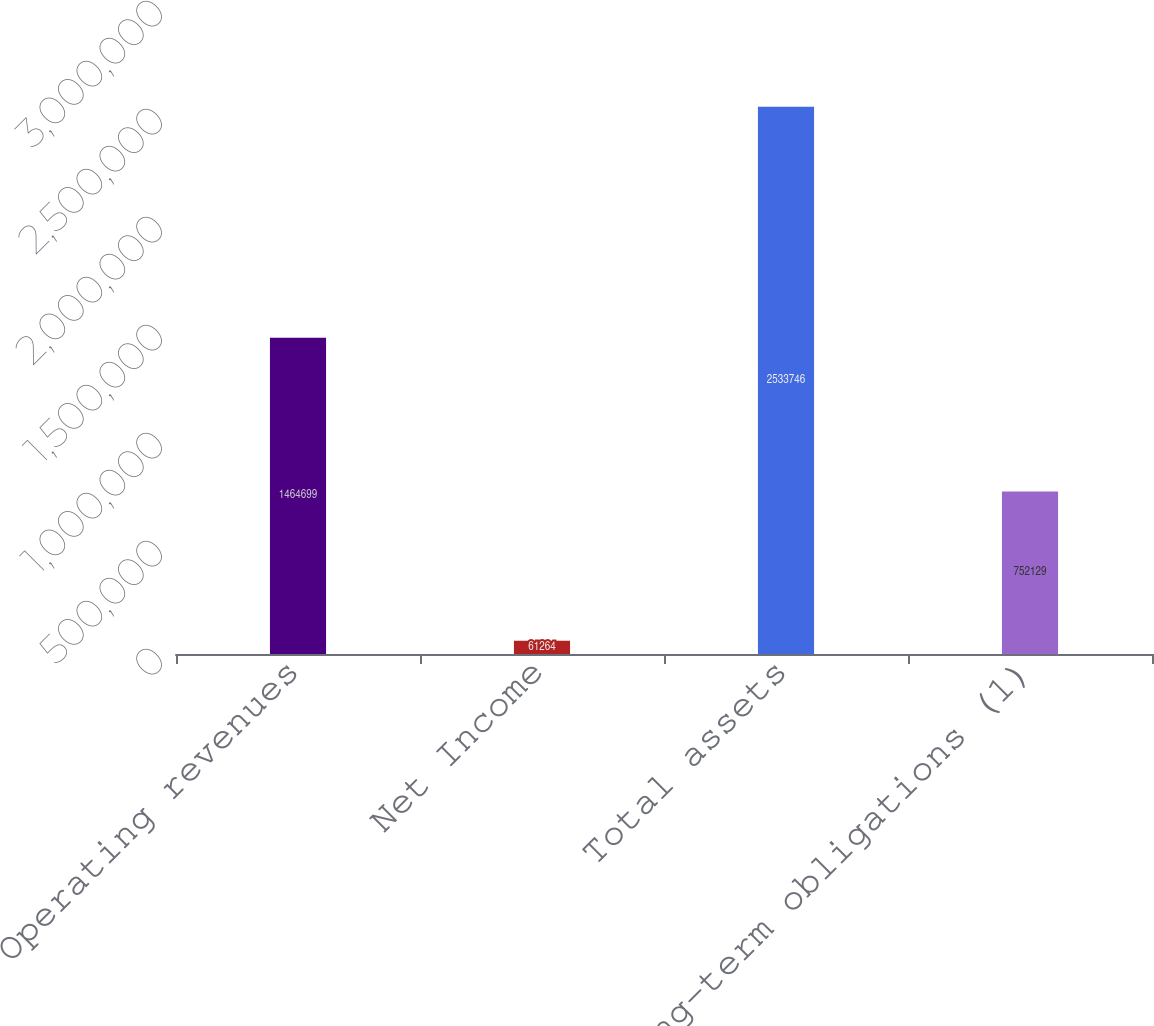<chart> <loc_0><loc_0><loc_500><loc_500><bar_chart><fcel>Operating revenues<fcel>Net Income<fcel>Total assets<fcel>Long-term obligations (1)<nl><fcel>1.4647e+06<fcel>61264<fcel>2.53375e+06<fcel>752129<nl></chart> 